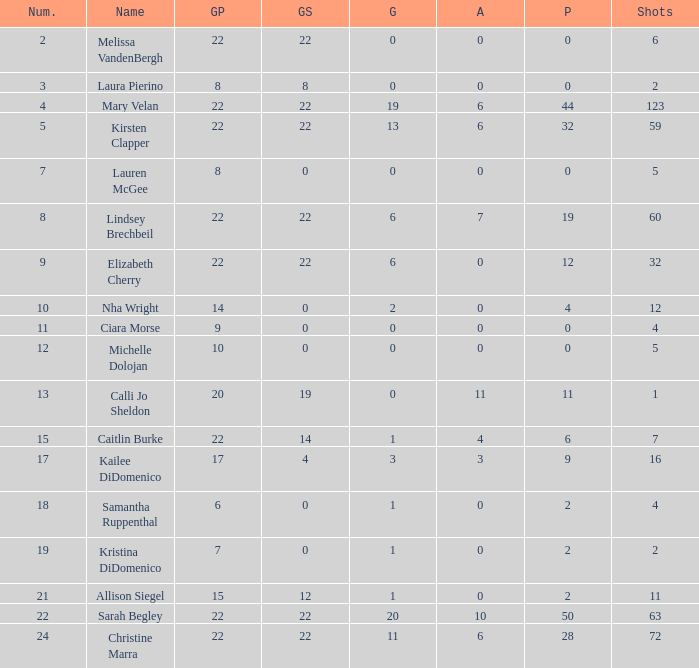How many names are listed for the player with 50 points? 1.0. 